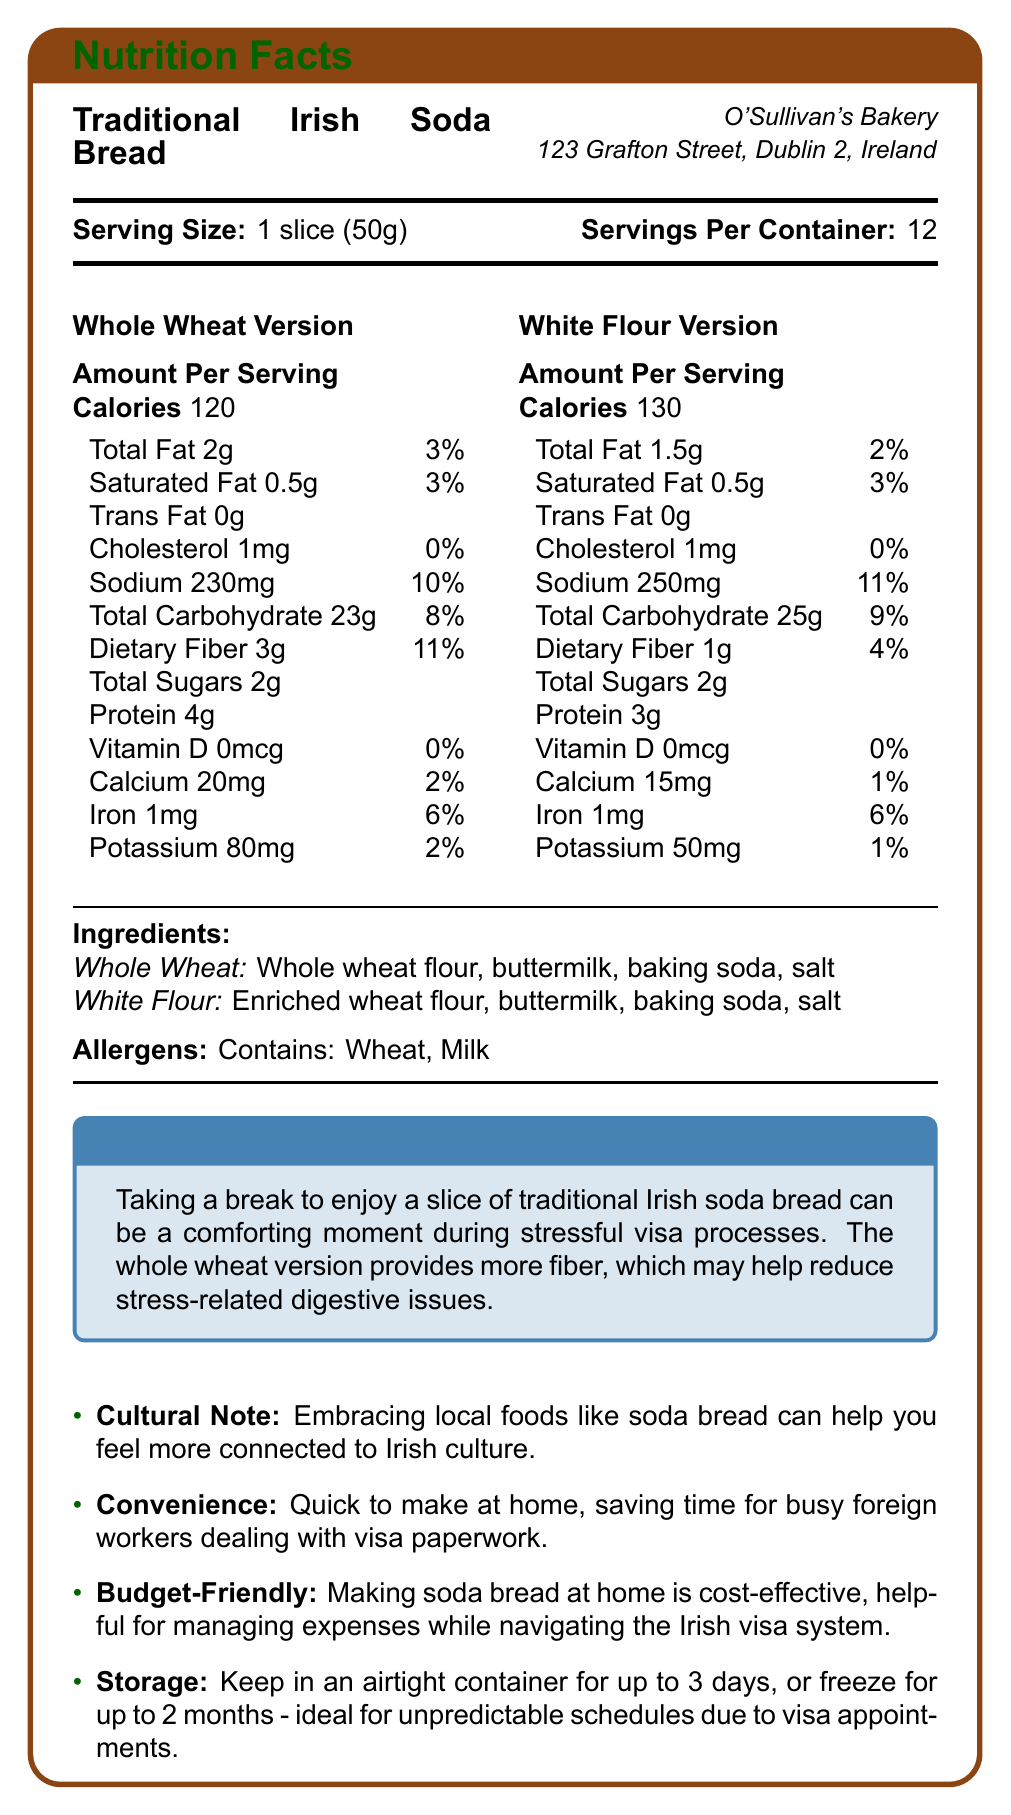Which version of Irish soda bread contains more calories per serving? The White Flour version has 130 calories, while the Whole Wheat version has 120 calories.
Answer: White Flour How much dietary fiber is in one serving of the whole wheat version? The Whole Wheat version has 3g dietary fiber per serving.
Answer: 3g What is the serving size for both versions of the soda bread? The serving size is stated as 1 slice (50g) for both versions.
Answer: 1 slice (50g) Which version of soda bread has a higher sodium content per serving? The White Flour version has 250mg of sodium, while the Whole Wheat version has 230mg of sodium.
Answer: White Flour What are the total sugars per serving in both versions of the soda bread? Both the Whole Wheat and White Flour versions have 2g of total sugars per serving.
Answer: 2g Which of the following nutrients is higher in the Whole Wheat version compared to the White Flour version? A. Calories B. Protein C. Total Carbohydrate D. Sodium The Whole Wheat version has 4g of protein compared to 3g in the White Flour version.
Answer: B. Protein What is the Daily Value percentage of iron in both versions? I. 2% II. 4% III. 6% IV. 10% Both the Whole Wheat and White Flour versions provide 6% of the Daily Value of iron.
Answer: III. 6% Does the Whole Wheat version contain more potassium than the White Flour version? The Whole Wheat version has 80mg of potassium compared to 50mg in the White Flour version.
Answer: Yes Describe the main idea of the document. The document includes detailed nutritional information and highlights specific features and tips relevant to foreign workers in Ireland, aiming to help them navigate stress and feel more connected to the local culture while managing their diet.
Answer: The document provides nutrition information for Traditional Irish Soda Bread in two versions (Whole Wheat and White Flour), produced by O'Sullivan's Bakery. It includes details such as calories, fat, cholesterol, carbohydrates, fiber, sugars, protein, vitamins, minerals, and ingredients. Additionally, it offers stress relief tips for foreign workers, emphasizes cultural connections, highlights convenience and budget-friendly aspects, and gives storage instructions. What is the cost of making the soda bread at home? The document mentions that making soda bread at home is cost-effective but does not provide specific cost details.
Answer: Not enough information 